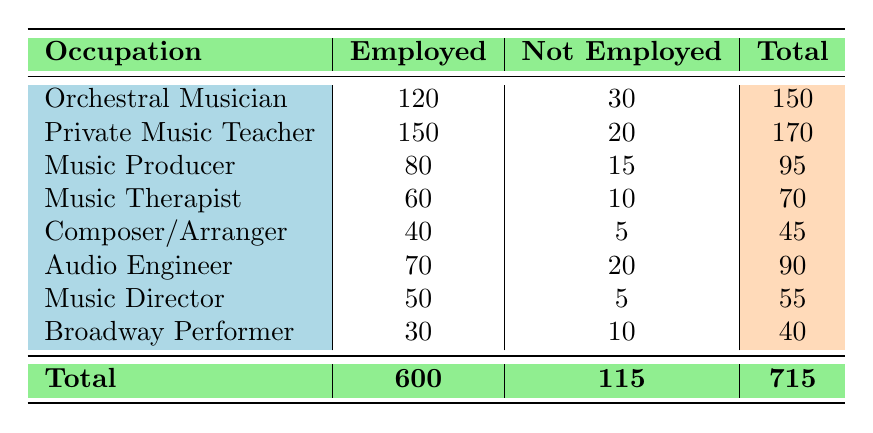What is the total number of employed graduates across all occupations listed? To find the total number of employed graduates, sum up all the "Employed" values in the table: 120 + 150 + 80 + 60 + 40 + 70 + 50 + 30 = 600.
Answer: 600 How many graduates are not employed as Music Therapists? According to the table, the "Not Employed" value for Music Therapists is 10.
Answer: 10 Which occupation has the highest number of employed graduates? By comparing the "Employed" numbers, Private Music Teacher has the highest at 150.
Answer: Private Music Teacher Is it true that the number of employed Music Producers is greater than the number of employed Music Directors? The number of employed Music Producers is 80, while employed Music Directors is 50. Since 80 is greater than 50, the statement is true.
Answer: Yes What is the total number of graduates for the occupation of Composer/Arranger? The total number of graduates for Composer/Arranger can be determined from the table by adding employed and not employed numbers: 40 + 5 = 45.
Answer: 45 What is the average number of employed graduates across the listed occupations? To find the average, sum the employed numbers (600) and divide by the number of occupations (8): 600 / 8 = 75.
Answer: 75 What is the difference between the number of employed and not employed graduates in the field of Audio Engineering? The number of employed graduates in Audio Engineering is 70 and not employed is 20. The difference is 70 - 20 = 50.
Answer: 50 Which occupation has the least number of employed graduates? By reviewing the "Employed" column, Composer/Arranger has the least number of employed graduates at 40.
Answer: Composer/Arranger What fraction of graduates are not employed across all occupations? To find the total number of not employed graduates, sum the "Not Employed" values: 30 + 20 + 15 + 10 + 5 + 20 + 5 + 10 = 115. The total number of graduates is 715, so the fraction is 115 / 715, which simplifies to approximately 0.161.
Answer: 0.161 